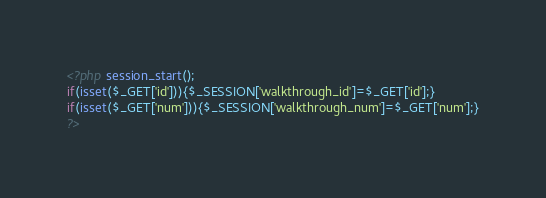<code> <loc_0><loc_0><loc_500><loc_500><_PHP_><?php session_start();
if(isset($_GET['id'])){$_SESSION['walkthrough_id']=$_GET['id'];}
if(isset($_GET['num'])){$_SESSION['walkthrough_num']=$_GET['num'];}
?></code> 